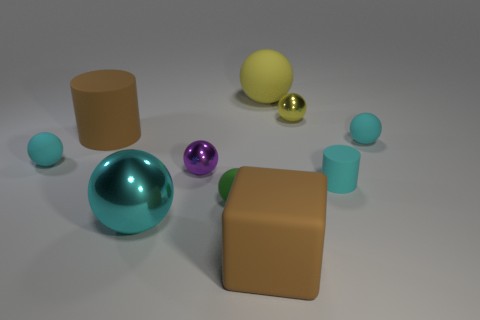Is there any other thing that is the same color as the matte cube?
Your answer should be very brief. Yes. What is the color of the tiny rubber ball behind the tiny cyan rubber object left of the brown rubber object that is behind the tiny purple metallic sphere?
Your answer should be very brief. Cyan. What size is the brown object that is in front of the tiny cyan matte sphere on the left side of the block?
Offer a very short reply. Large. The big object that is both behind the small green matte thing and to the left of the small green rubber sphere is made of what material?
Your response must be concise. Rubber. There is a brown block; is its size the same as the cyan rubber ball that is on the right side of the cyan metallic thing?
Keep it short and to the point. No. Is there a big brown rubber cylinder?
Offer a very short reply. Yes. There is a green thing that is the same shape as the cyan shiny thing; what material is it?
Offer a very short reply. Rubber. There is a rubber ball behind the metallic thing behind the small metal thing that is to the left of the green matte object; what is its size?
Offer a very short reply. Large. There is a cyan metal thing; are there any purple metallic things in front of it?
Offer a terse response. No. There is a brown cylinder that is the same material as the small cyan cylinder; what size is it?
Provide a succinct answer. Large. 